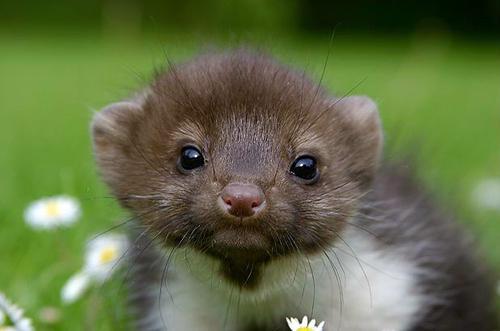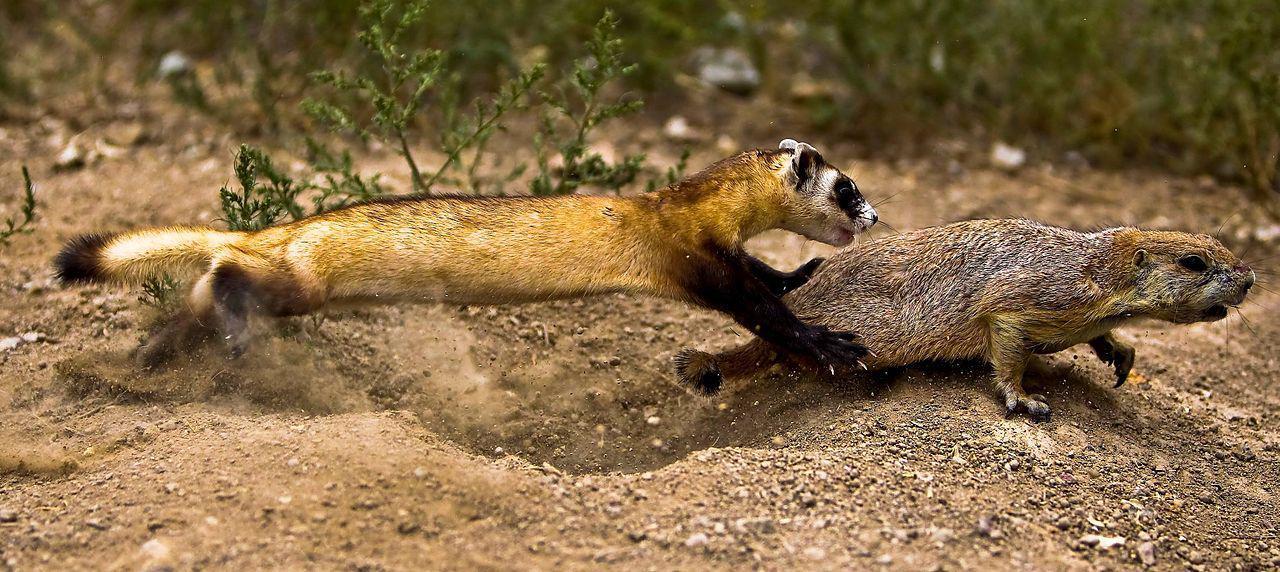The first image is the image on the left, the second image is the image on the right. Analyze the images presented: Is the assertion "There are at least three total rodents." valid? Answer yes or no. Yes. 